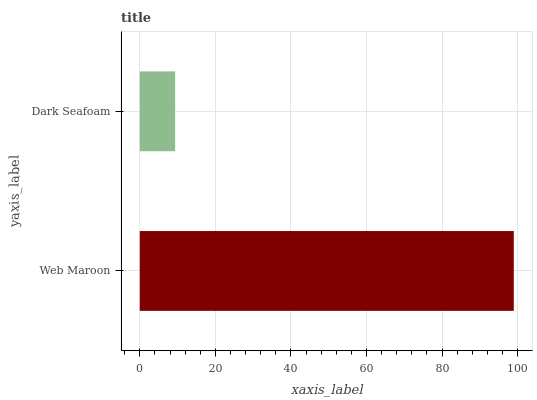Is Dark Seafoam the minimum?
Answer yes or no. Yes. Is Web Maroon the maximum?
Answer yes or no. Yes. Is Dark Seafoam the maximum?
Answer yes or no. No. Is Web Maroon greater than Dark Seafoam?
Answer yes or no. Yes. Is Dark Seafoam less than Web Maroon?
Answer yes or no. Yes. Is Dark Seafoam greater than Web Maroon?
Answer yes or no. No. Is Web Maroon less than Dark Seafoam?
Answer yes or no. No. Is Web Maroon the high median?
Answer yes or no. Yes. Is Dark Seafoam the low median?
Answer yes or no. Yes. Is Dark Seafoam the high median?
Answer yes or no. No. Is Web Maroon the low median?
Answer yes or no. No. 